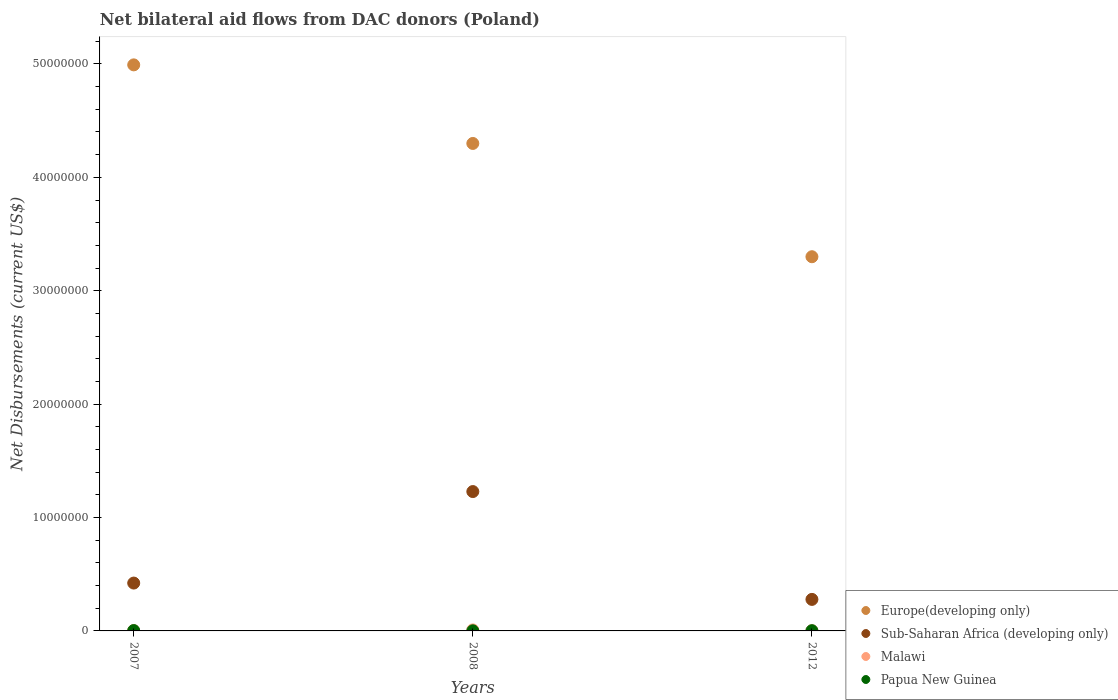What is the total net bilateral aid flows in Europe(developing only) in the graph?
Offer a terse response. 1.26e+08. What is the difference between the net bilateral aid flows in Europe(developing only) in 2007 and that in 2008?
Your response must be concise. 6.93e+06. What is the difference between the net bilateral aid flows in Papua New Guinea in 2008 and the net bilateral aid flows in Sub-Saharan Africa (developing only) in 2012?
Your answer should be very brief. -2.77e+06. What is the average net bilateral aid flows in Malawi per year?
Provide a short and direct response. 4.67e+04. In the year 2007, what is the difference between the net bilateral aid flows in Sub-Saharan Africa (developing only) and net bilateral aid flows in Papua New Guinea?
Keep it short and to the point. 4.19e+06. In how many years, is the net bilateral aid flows in Papua New Guinea greater than 24000000 US$?
Your answer should be very brief. 0. What is the ratio of the net bilateral aid flows in Sub-Saharan Africa (developing only) in 2007 to that in 2008?
Make the answer very short. 0.34. What is the difference between the highest and the second highest net bilateral aid flows in Papua New Guinea?
Offer a very short reply. 10000. In how many years, is the net bilateral aid flows in Papua New Guinea greater than the average net bilateral aid flows in Papua New Guinea taken over all years?
Provide a succinct answer. 1. Is the sum of the net bilateral aid flows in Malawi in 2007 and 2012 greater than the maximum net bilateral aid flows in Europe(developing only) across all years?
Offer a very short reply. No. Is it the case that in every year, the sum of the net bilateral aid flows in Sub-Saharan Africa (developing only) and net bilateral aid flows in Malawi  is greater than the sum of net bilateral aid flows in Europe(developing only) and net bilateral aid flows in Papua New Guinea?
Your answer should be compact. Yes. Is it the case that in every year, the sum of the net bilateral aid flows in Sub-Saharan Africa (developing only) and net bilateral aid flows in Papua New Guinea  is greater than the net bilateral aid flows in Europe(developing only)?
Offer a terse response. No. Is the net bilateral aid flows in Europe(developing only) strictly greater than the net bilateral aid flows in Sub-Saharan Africa (developing only) over the years?
Provide a succinct answer. Yes. How many years are there in the graph?
Ensure brevity in your answer.  3. Are the values on the major ticks of Y-axis written in scientific E-notation?
Your response must be concise. No. How many legend labels are there?
Ensure brevity in your answer.  4. How are the legend labels stacked?
Your response must be concise. Vertical. What is the title of the graph?
Your answer should be very brief. Net bilateral aid flows from DAC donors (Poland). Does "South Sudan" appear as one of the legend labels in the graph?
Your response must be concise. No. What is the label or title of the X-axis?
Your answer should be very brief. Years. What is the label or title of the Y-axis?
Offer a terse response. Net Disbursements (current US$). What is the Net Disbursements (current US$) of Europe(developing only) in 2007?
Provide a succinct answer. 4.99e+07. What is the Net Disbursements (current US$) of Sub-Saharan Africa (developing only) in 2007?
Give a very brief answer. 4.22e+06. What is the Net Disbursements (current US$) in Papua New Guinea in 2007?
Ensure brevity in your answer.  3.00e+04. What is the Net Disbursements (current US$) of Europe(developing only) in 2008?
Give a very brief answer. 4.30e+07. What is the Net Disbursements (current US$) of Sub-Saharan Africa (developing only) in 2008?
Offer a very short reply. 1.23e+07. What is the Net Disbursements (current US$) of Malawi in 2008?
Provide a short and direct response. 9.00e+04. What is the Net Disbursements (current US$) in Papua New Guinea in 2008?
Keep it short and to the point. 10000. What is the Net Disbursements (current US$) in Europe(developing only) in 2012?
Make the answer very short. 3.30e+07. What is the Net Disbursements (current US$) of Sub-Saharan Africa (developing only) in 2012?
Provide a succinct answer. 2.78e+06. What is the Net Disbursements (current US$) in Malawi in 2012?
Ensure brevity in your answer.  2.00e+04. Across all years, what is the maximum Net Disbursements (current US$) of Europe(developing only)?
Your answer should be compact. 4.99e+07. Across all years, what is the maximum Net Disbursements (current US$) in Sub-Saharan Africa (developing only)?
Ensure brevity in your answer.  1.23e+07. Across all years, what is the minimum Net Disbursements (current US$) of Europe(developing only)?
Your answer should be very brief. 3.30e+07. Across all years, what is the minimum Net Disbursements (current US$) in Sub-Saharan Africa (developing only)?
Provide a short and direct response. 2.78e+06. Across all years, what is the minimum Net Disbursements (current US$) in Malawi?
Offer a terse response. 2.00e+04. Across all years, what is the minimum Net Disbursements (current US$) of Papua New Guinea?
Your answer should be very brief. 10000. What is the total Net Disbursements (current US$) of Europe(developing only) in the graph?
Your response must be concise. 1.26e+08. What is the total Net Disbursements (current US$) of Sub-Saharan Africa (developing only) in the graph?
Your response must be concise. 1.93e+07. What is the total Net Disbursements (current US$) in Malawi in the graph?
Make the answer very short. 1.40e+05. What is the total Net Disbursements (current US$) of Papua New Guinea in the graph?
Offer a very short reply. 6.00e+04. What is the difference between the Net Disbursements (current US$) in Europe(developing only) in 2007 and that in 2008?
Your answer should be compact. 6.93e+06. What is the difference between the Net Disbursements (current US$) of Sub-Saharan Africa (developing only) in 2007 and that in 2008?
Your answer should be compact. -8.07e+06. What is the difference between the Net Disbursements (current US$) in Malawi in 2007 and that in 2008?
Make the answer very short. -6.00e+04. What is the difference between the Net Disbursements (current US$) of Europe(developing only) in 2007 and that in 2012?
Offer a very short reply. 1.69e+07. What is the difference between the Net Disbursements (current US$) in Sub-Saharan Africa (developing only) in 2007 and that in 2012?
Offer a terse response. 1.44e+06. What is the difference between the Net Disbursements (current US$) in Europe(developing only) in 2008 and that in 2012?
Your answer should be very brief. 9.99e+06. What is the difference between the Net Disbursements (current US$) in Sub-Saharan Africa (developing only) in 2008 and that in 2012?
Provide a short and direct response. 9.51e+06. What is the difference between the Net Disbursements (current US$) in Malawi in 2008 and that in 2012?
Make the answer very short. 7.00e+04. What is the difference between the Net Disbursements (current US$) of Papua New Guinea in 2008 and that in 2012?
Make the answer very short. -10000. What is the difference between the Net Disbursements (current US$) in Europe(developing only) in 2007 and the Net Disbursements (current US$) in Sub-Saharan Africa (developing only) in 2008?
Give a very brief answer. 3.76e+07. What is the difference between the Net Disbursements (current US$) in Europe(developing only) in 2007 and the Net Disbursements (current US$) in Malawi in 2008?
Your answer should be very brief. 4.98e+07. What is the difference between the Net Disbursements (current US$) of Europe(developing only) in 2007 and the Net Disbursements (current US$) of Papua New Guinea in 2008?
Ensure brevity in your answer.  4.99e+07. What is the difference between the Net Disbursements (current US$) in Sub-Saharan Africa (developing only) in 2007 and the Net Disbursements (current US$) in Malawi in 2008?
Offer a very short reply. 4.13e+06. What is the difference between the Net Disbursements (current US$) of Sub-Saharan Africa (developing only) in 2007 and the Net Disbursements (current US$) of Papua New Guinea in 2008?
Provide a short and direct response. 4.21e+06. What is the difference between the Net Disbursements (current US$) of Malawi in 2007 and the Net Disbursements (current US$) of Papua New Guinea in 2008?
Ensure brevity in your answer.  2.00e+04. What is the difference between the Net Disbursements (current US$) of Europe(developing only) in 2007 and the Net Disbursements (current US$) of Sub-Saharan Africa (developing only) in 2012?
Give a very brief answer. 4.71e+07. What is the difference between the Net Disbursements (current US$) of Europe(developing only) in 2007 and the Net Disbursements (current US$) of Malawi in 2012?
Keep it short and to the point. 4.99e+07. What is the difference between the Net Disbursements (current US$) in Europe(developing only) in 2007 and the Net Disbursements (current US$) in Papua New Guinea in 2012?
Give a very brief answer. 4.99e+07. What is the difference between the Net Disbursements (current US$) in Sub-Saharan Africa (developing only) in 2007 and the Net Disbursements (current US$) in Malawi in 2012?
Your answer should be compact. 4.20e+06. What is the difference between the Net Disbursements (current US$) of Sub-Saharan Africa (developing only) in 2007 and the Net Disbursements (current US$) of Papua New Guinea in 2012?
Provide a succinct answer. 4.20e+06. What is the difference between the Net Disbursements (current US$) of Malawi in 2007 and the Net Disbursements (current US$) of Papua New Guinea in 2012?
Give a very brief answer. 10000. What is the difference between the Net Disbursements (current US$) in Europe(developing only) in 2008 and the Net Disbursements (current US$) in Sub-Saharan Africa (developing only) in 2012?
Ensure brevity in your answer.  4.02e+07. What is the difference between the Net Disbursements (current US$) in Europe(developing only) in 2008 and the Net Disbursements (current US$) in Malawi in 2012?
Give a very brief answer. 4.30e+07. What is the difference between the Net Disbursements (current US$) of Europe(developing only) in 2008 and the Net Disbursements (current US$) of Papua New Guinea in 2012?
Provide a short and direct response. 4.30e+07. What is the difference between the Net Disbursements (current US$) in Sub-Saharan Africa (developing only) in 2008 and the Net Disbursements (current US$) in Malawi in 2012?
Offer a very short reply. 1.23e+07. What is the difference between the Net Disbursements (current US$) in Sub-Saharan Africa (developing only) in 2008 and the Net Disbursements (current US$) in Papua New Guinea in 2012?
Ensure brevity in your answer.  1.23e+07. What is the difference between the Net Disbursements (current US$) in Malawi in 2008 and the Net Disbursements (current US$) in Papua New Guinea in 2012?
Keep it short and to the point. 7.00e+04. What is the average Net Disbursements (current US$) in Europe(developing only) per year?
Make the answer very short. 4.20e+07. What is the average Net Disbursements (current US$) of Sub-Saharan Africa (developing only) per year?
Keep it short and to the point. 6.43e+06. What is the average Net Disbursements (current US$) in Malawi per year?
Provide a short and direct response. 4.67e+04. In the year 2007, what is the difference between the Net Disbursements (current US$) of Europe(developing only) and Net Disbursements (current US$) of Sub-Saharan Africa (developing only)?
Your answer should be very brief. 4.57e+07. In the year 2007, what is the difference between the Net Disbursements (current US$) in Europe(developing only) and Net Disbursements (current US$) in Malawi?
Offer a terse response. 4.99e+07. In the year 2007, what is the difference between the Net Disbursements (current US$) of Europe(developing only) and Net Disbursements (current US$) of Papua New Guinea?
Provide a short and direct response. 4.99e+07. In the year 2007, what is the difference between the Net Disbursements (current US$) in Sub-Saharan Africa (developing only) and Net Disbursements (current US$) in Malawi?
Ensure brevity in your answer.  4.19e+06. In the year 2007, what is the difference between the Net Disbursements (current US$) of Sub-Saharan Africa (developing only) and Net Disbursements (current US$) of Papua New Guinea?
Provide a short and direct response. 4.19e+06. In the year 2008, what is the difference between the Net Disbursements (current US$) in Europe(developing only) and Net Disbursements (current US$) in Sub-Saharan Africa (developing only)?
Make the answer very short. 3.07e+07. In the year 2008, what is the difference between the Net Disbursements (current US$) of Europe(developing only) and Net Disbursements (current US$) of Malawi?
Ensure brevity in your answer.  4.29e+07. In the year 2008, what is the difference between the Net Disbursements (current US$) in Europe(developing only) and Net Disbursements (current US$) in Papua New Guinea?
Offer a very short reply. 4.30e+07. In the year 2008, what is the difference between the Net Disbursements (current US$) in Sub-Saharan Africa (developing only) and Net Disbursements (current US$) in Malawi?
Your answer should be compact. 1.22e+07. In the year 2008, what is the difference between the Net Disbursements (current US$) in Sub-Saharan Africa (developing only) and Net Disbursements (current US$) in Papua New Guinea?
Offer a terse response. 1.23e+07. In the year 2012, what is the difference between the Net Disbursements (current US$) of Europe(developing only) and Net Disbursements (current US$) of Sub-Saharan Africa (developing only)?
Give a very brief answer. 3.02e+07. In the year 2012, what is the difference between the Net Disbursements (current US$) of Europe(developing only) and Net Disbursements (current US$) of Malawi?
Offer a very short reply. 3.30e+07. In the year 2012, what is the difference between the Net Disbursements (current US$) in Europe(developing only) and Net Disbursements (current US$) in Papua New Guinea?
Make the answer very short. 3.30e+07. In the year 2012, what is the difference between the Net Disbursements (current US$) of Sub-Saharan Africa (developing only) and Net Disbursements (current US$) of Malawi?
Your response must be concise. 2.76e+06. In the year 2012, what is the difference between the Net Disbursements (current US$) in Sub-Saharan Africa (developing only) and Net Disbursements (current US$) in Papua New Guinea?
Keep it short and to the point. 2.76e+06. What is the ratio of the Net Disbursements (current US$) of Europe(developing only) in 2007 to that in 2008?
Provide a succinct answer. 1.16. What is the ratio of the Net Disbursements (current US$) in Sub-Saharan Africa (developing only) in 2007 to that in 2008?
Give a very brief answer. 0.34. What is the ratio of the Net Disbursements (current US$) of Papua New Guinea in 2007 to that in 2008?
Offer a terse response. 3. What is the ratio of the Net Disbursements (current US$) in Europe(developing only) in 2007 to that in 2012?
Your answer should be very brief. 1.51. What is the ratio of the Net Disbursements (current US$) of Sub-Saharan Africa (developing only) in 2007 to that in 2012?
Provide a short and direct response. 1.52. What is the ratio of the Net Disbursements (current US$) in Malawi in 2007 to that in 2012?
Your answer should be compact. 1.5. What is the ratio of the Net Disbursements (current US$) in Europe(developing only) in 2008 to that in 2012?
Your answer should be compact. 1.3. What is the ratio of the Net Disbursements (current US$) in Sub-Saharan Africa (developing only) in 2008 to that in 2012?
Offer a very short reply. 4.42. What is the ratio of the Net Disbursements (current US$) in Malawi in 2008 to that in 2012?
Give a very brief answer. 4.5. What is the ratio of the Net Disbursements (current US$) in Papua New Guinea in 2008 to that in 2012?
Offer a terse response. 0.5. What is the difference between the highest and the second highest Net Disbursements (current US$) in Europe(developing only)?
Offer a very short reply. 6.93e+06. What is the difference between the highest and the second highest Net Disbursements (current US$) in Sub-Saharan Africa (developing only)?
Provide a short and direct response. 8.07e+06. What is the difference between the highest and the second highest Net Disbursements (current US$) of Papua New Guinea?
Ensure brevity in your answer.  10000. What is the difference between the highest and the lowest Net Disbursements (current US$) in Europe(developing only)?
Keep it short and to the point. 1.69e+07. What is the difference between the highest and the lowest Net Disbursements (current US$) of Sub-Saharan Africa (developing only)?
Give a very brief answer. 9.51e+06. What is the difference between the highest and the lowest Net Disbursements (current US$) in Malawi?
Offer a very short reply. 7.00e+04. 